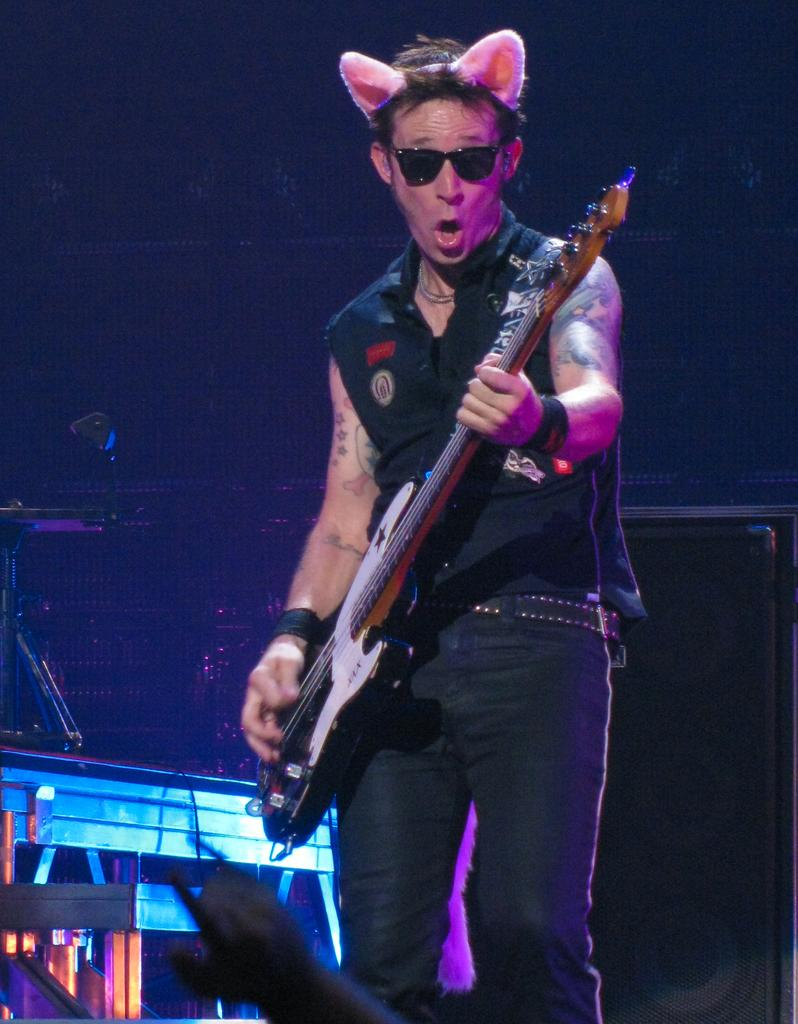What is the man in the image doing? The man is playing a guitar. What object is present in the background of the image? There is a microphone in the background of the image. How many musical instruments can be seen in the background of the image? There are at least two musical instruments in the background of the image. What type of education is the man receiving in the image? There is no indication in the image that the man is receiving any education. 